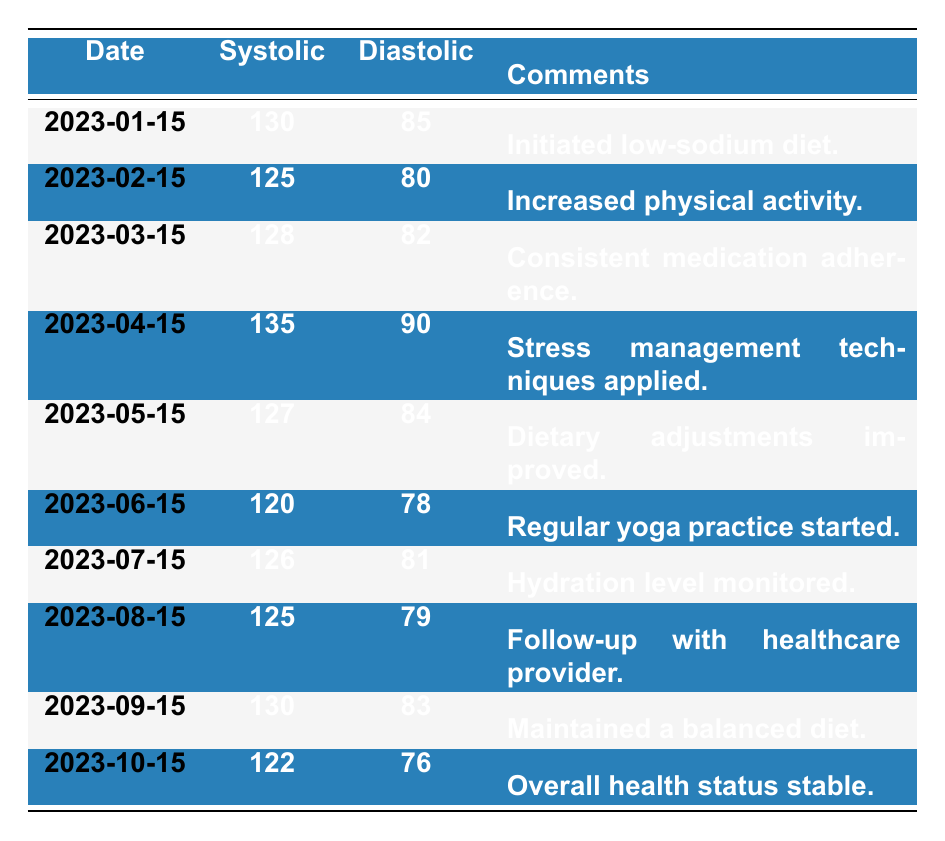What was the systolic blood pressure on March 15, 2023? The table shows the systolic blood pressure reading for March 15, 2023, as 128.
Answer: 128 What is the diastolic blood pressure reading on June 15, 2023? From the table, the diastolic pressure on June 15, 2023, is listed as 78.
Answer: 78 Was there a change in systolic blood pressure from January 15 to February 15, 2023? On January 15, the systolic reading was 130 and on February 15, it was 125. This indicates a decrease of 5.
Answer: Yes What was the average diastolic blood pressure over the reported period? To find the average, we sum the diastolic values: 85 + 80 + 82 + 90 + 84 + 78 + 81 + 79 + 83 + 76 =  835. Then, we divide by the number of readings (10), resulting in 83.5.
Answer: 83.5 Did the blood pressure readings remain consistent throughout the year? By observing the table, we note fluctuations: starting at 130 and varying down to 120. This shows inconsistency with peaks and valleys.
Answer: No What is the highest systolic blood pressure recorded in the given period? Scanning through the systolic values, the highest recorded value is 135 on April 15, 2023.
Answer: 135 Is there a noticeable trend in diastolic pressure from January to October? Analyzing all the readings, the diastolic pressure starts at 85 in January and ends at 76 in October, exhibiting a downward trend overall.
Answer: Yes What was the systolic blood pressure difference between September 15 and February 15? The systolic blood pressure on September 15 was 130, whereas on February 15, it was 125. The difference, therefore, is 130 - 125 = 5.
Answer: 5 Which month showed the lowest diastolic blood pressure reading? The table indicates the lowest diastolic reading of 76 occurred in October.
Answer: October 